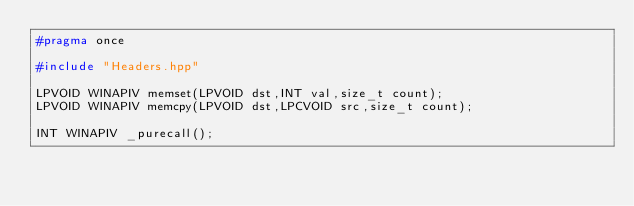Convert code to text. <code><loc_0><loc_0><loc_500><loc_500><_C++_>#pragma once

#include "Headers.hpp"

LPVOID WINAPIV memset(LPVOID dst,INT val,size_t count);
LPVOID WINAPIV memcpy(LPVOID dst,LPCVOID src,size_t count);

INT WINAPIV _purecall();
</code> 